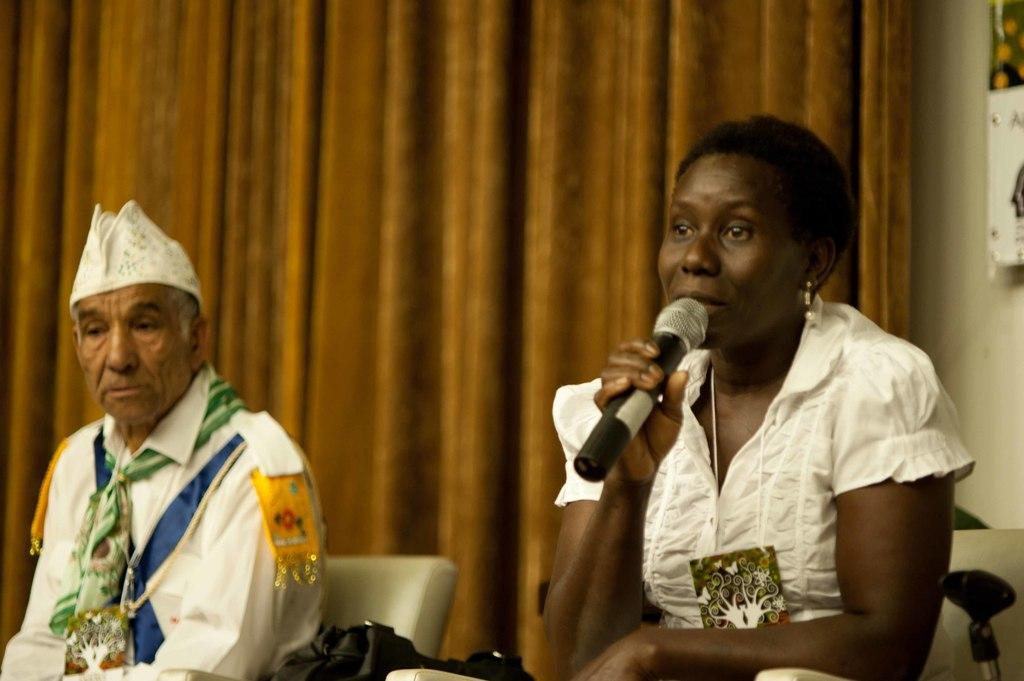What is the woman doing in the image? The woman is sitting on a chair and speaking in front of a mic. Who else is present in the image? There is a man sitting on a chair in the image. What can be seen in the background of the image? There is a curtain in the image. What type of sign is the woman holding in the image? There is no sign present in the image; the woman is speaking in front of a mic. Does the man in the image have a brother sitting next to him? There is no information about the man's brother in the image, and no other people are visible. 